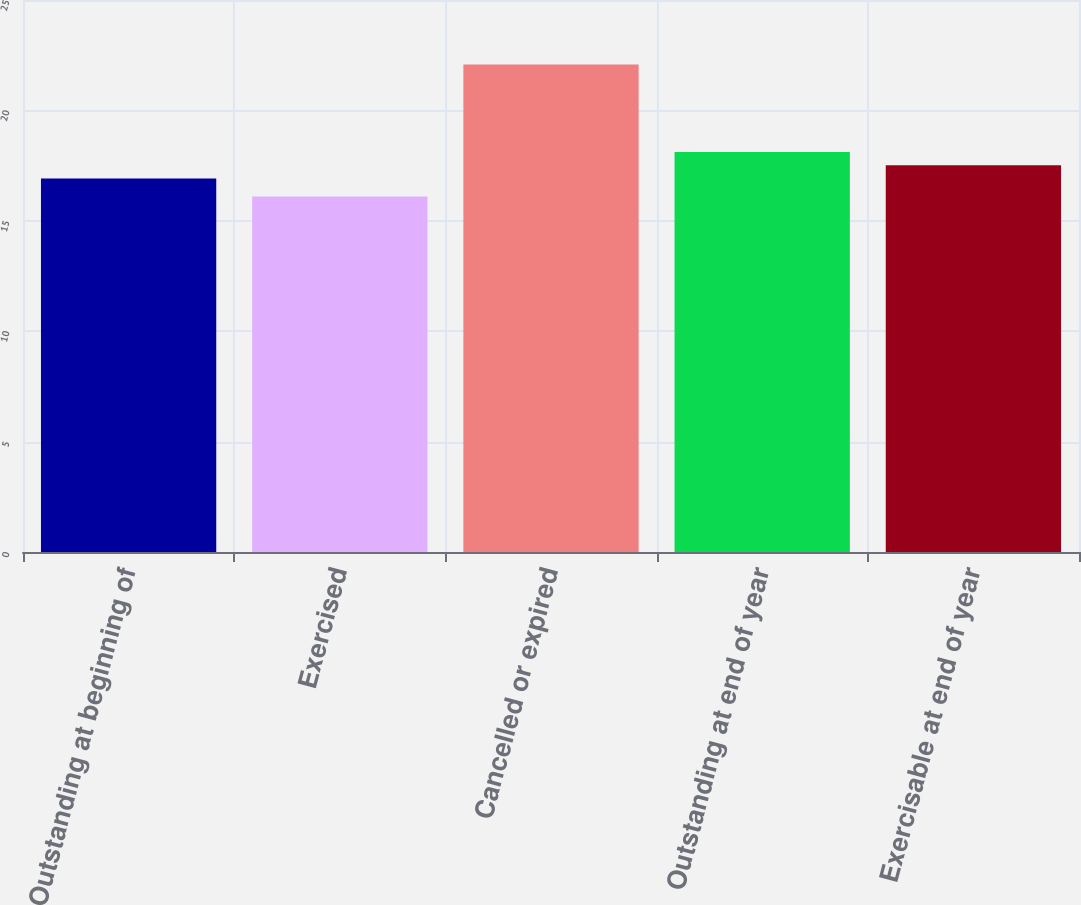<chart> <loc_0><loc_0><loc_500><loc_500><bar_chart><fcel>Outstanding at beginning of<fcel>Exercised<fcel>Cancelled or expired<fcel>Outstanding at end of year<fcel>Exercisable at end of year<nl><fcel>16.92<fcel>16.1<fcel>22.08<fcel>18.12<fcel>17.52<nl></chart> 